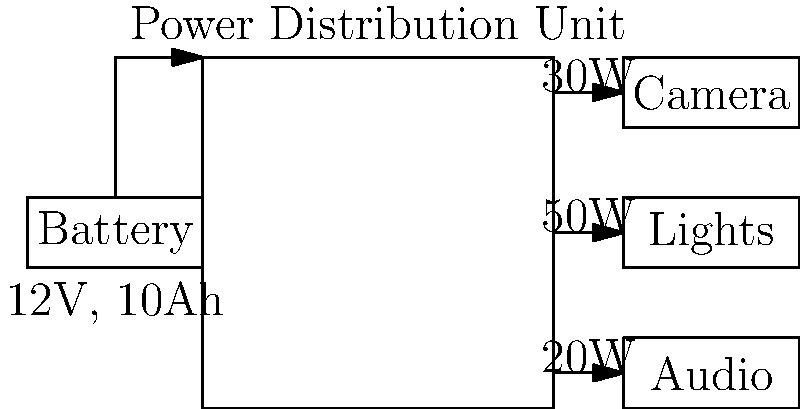For a mobile salsa performance video setup, you have a 12V battery rated at 10Ah powering a camera (30W), lights (50W), and audio equipment (20W) through a power distribution unit. Assuming the system operates at maximum power for 2 hours, calculate:

a) The total power consumption of the setup
b) The total current draw from the battery
c) The battery's capacity utilization percentage after 2 hours of operation Let's approach this step-by-step:

1) Calculate the total power consumption:
   Total power = Camera power + Lights power + Audio power
   Total power = 30W + 50W + 20W = 100W

2) Calculate the current draw:
   Using the formula $P = V \times I$, where P is power, V is voltage, and I is current:
   $100W = 12V \times I$
   $I = 100W / 12V = 8.33A$

3) Calculate the battery capacity utilization:
   - The battery capacity is given in Amp-hours (Ah)
   - We need to find how many Amp-hours are used in 2 hours
   Amp-hours used = Current × Time
   Amp-hours used = 8.33A × 2h = 16.67Ah

4) Calculate the battery capacity utilization percentage:
   Utilization percentage = (Amp-hours used / Battery capacity) × 100%
   Utilization percentage = (16.67Ah / 10Ah) × 100% = 166.7%

This means that after 2 hours, the setup would require 166.7% of the battery's capacity, which is not possible. The battery would be completely drained before 2 hours of operation.

To find the actual operation time:
Time = Battery capacity / Current draw
Time = 10Ah / 8.33A = 1.2 hours or 72 minutes
Answer: a) 100W
b) 8.33A
c) 166.7% (battery depleted in 72 minutes) 